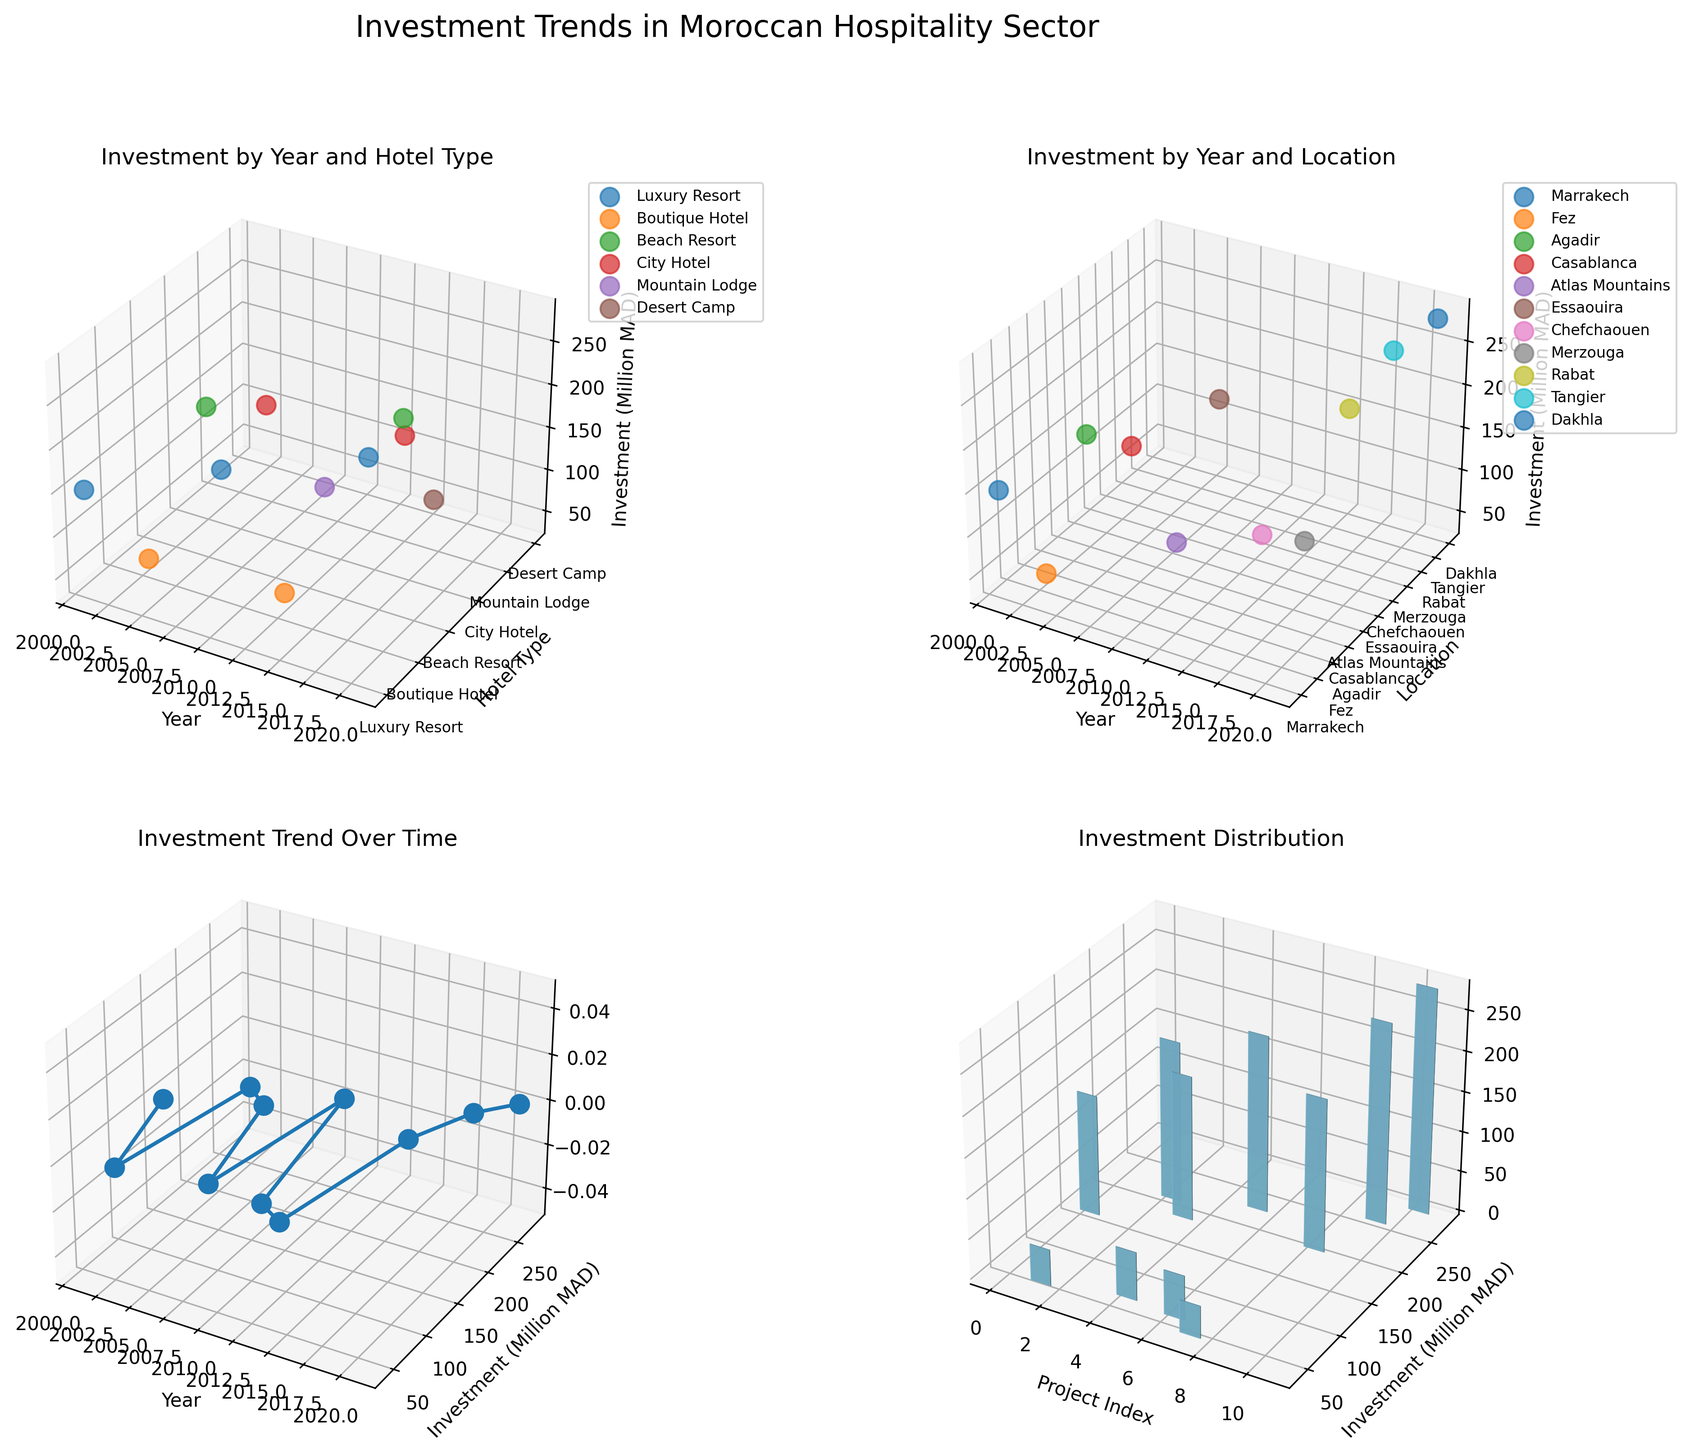What's the title of the overall figure? The overall title is located at the top center of the entire figure. It says "Investment Trends in Moroccan Hospitality Sector".
Answer: Investment Trends in Moroccan Hospitality Sector Which subplot shows the trend of investment over time? The subplot located at the bottom-left, labeled "Investment Trend Over Time," shows the trend of investment over time. This is indicated by its title and the use of a line plot representing years on the x-axis and investment amounts on the y-axis.
Answer: Bottom-left subplot What is the most invested location over the past 20 years? To find the most invested location, observe the bottom-right subplot titled "Investment Distribution." The location with the tallest bars represents the highest total investment across all projects. Tangier, with an investment of 250 million MAD in 2019, appears to be the highest.
Answer: Tangier Which hotel type has the highest average investment? To find the highest average investment by hotel type, refer to the top-left subplot titled "Investment by Year and Hotel Type." Identifying the highest scattered points gives an indication of higher averages. The "Luxury Resort" category, with investments of 150, 220, and 280 million MAD, stands out. Calculating the average of these values gives (150 + 220 + 280) / 3 = 216.7 million MAD, indicating it has the highest average investment.
Answer: Luxury Resort Between Marrakech and Casablanca, which city had greater investment in 2007? Look for the subplot on the top-right titled "Investment by Year and Location" to compare Marrakech and Casablanca in 2007. The data points for 2007 show no investments in Marrakech, while Casablanca has an investment of 180 million MAD.
Answer: Casablanca What's the cumulative investment in Boutique Hotels? Review the top-left subplot titled "Investment by Year and Hotel Type" for Boutique Hotels and sum their investments. The points for Boutique Hotels are at 45 (2003) and 55 (2013) million MAD. Summing these gives 45 + 55 = 100 million MAD.
Answer: 100 million MAD Which year's investment showed the highest increase compared to its previous point? Analyze the bottom-left subplot titled "Investment Trend Over Time" for the investment increase between successive years. The largest increase is between 2019 (250 million MAD) to 2021 (280 million MAD), showing an increase of 280 - 250 = 30 million MAD.
Answer: 2021 What's the range of investments in Beach Resorts? Refer to the top-left subplot titled "Investment by Year and Hotel Type" to find Beach Resorts investments at 2005 (200 million MAD) and 2019 (250 million MAD). The range is calculated as 250 - 200 = 50 million MAD.
Answer: 50 million MAD How many different cultural elements are incorporated across the dataset? Examine the dataset for unique cultural elements. The unique cultural elements listed include Traditional Riads, Moroccan Crafts, Berber Influence, Modern Arabic Design, Kasbah Architecture, Coastal Heritage, Blue City Aesthetics, Saharan Traditions, Royal Moroccan Style, and Mediterranean Fusion. There are 10 unique cultural elements in total.
Answer: 10 